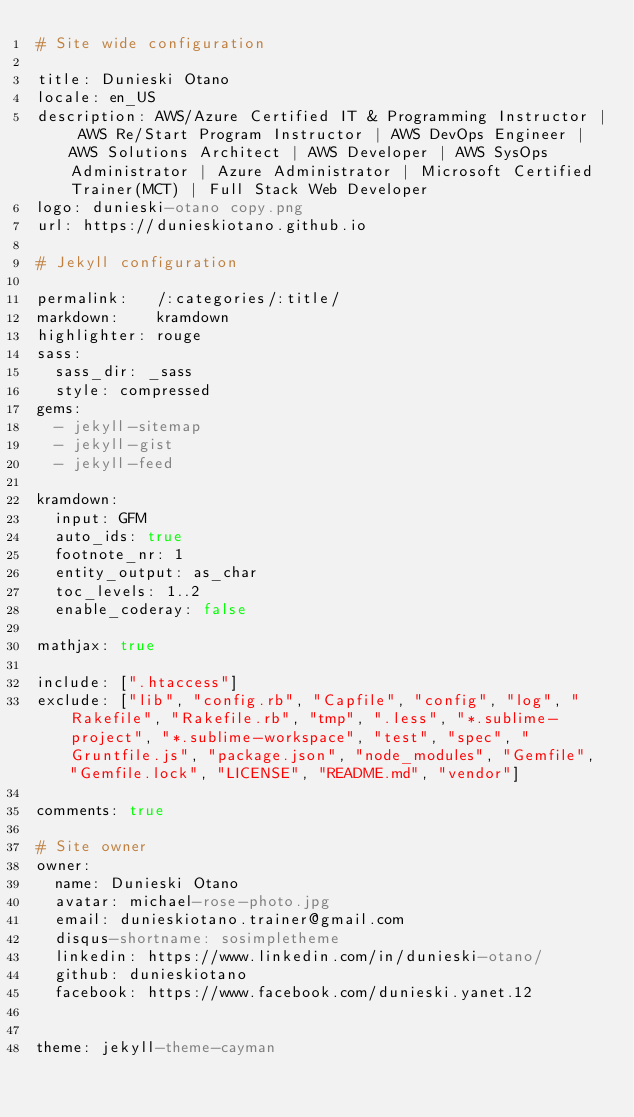Convert code to text. <code><loc_0><loc_0><loc_500><loc_500><_YAML_># Site wide configuration

title: Dunieski Otano
locale: en_US
description: AWS/Azure Certified IT & Programming Instructor | AWS Re/Start Program Instructor | AWS DevOps Engineer | AWS Solutions Architect | AWS Developer | AWS SysOps Administrator | Azure Administrator | Microsoft Certified Trainer(MCT) | Full Stack Web Developer
logo: dunieski-otano copy.png
url: https://dunieskiotano.github.io

# Jekyll configuration

permalink:   /:categories/:title/
markdown:    kramdown
highlighter: rouge
sass:
  sass_dir: _sass
  style: compressed
gems:
  - jekyll-sitemap
  - jekyll-gist
  - jekyll-feed

kramdown:
  input: GFM
  auto_ids: true
  footnote_nr: 1
  entity_output: as_char
  toc_levels: 1..2
  enable_coderay: false

mathjax: true

include: [".htaccess"]
exclude: ["lib", "config.rb", "Capfile", "config", "log", "Rakefile", "Rakefile.rb", "tmp", ".less", "*.sublime-project", "*.sublime-workspace", "test", "spec", "Gruntfile.js", "package.json", "node_modules", "Gemfile", "Gemfile.lock", "LICENSE", "README.md", "vendor"]

comments: true

# Site owner
owner:
  name: Dunieski Otano
  avatar: michael-rose-photo.jpg
  email: dunieskiotano.trainer@gmail.com
  disqus-shortname: sosimpletheme
  linkedin: https://www.linkedin.com/in/dunieski-otano/
  github: dunieskiotano
  facebook: https://www.facebook.com/dunieski.yanet.12
  

theme: jekyll-theme-cayman

</code> 